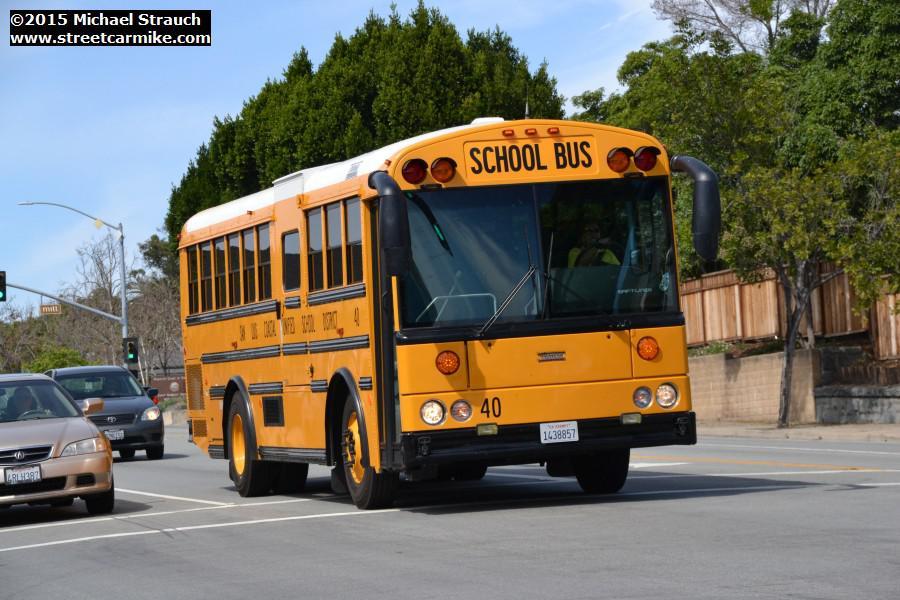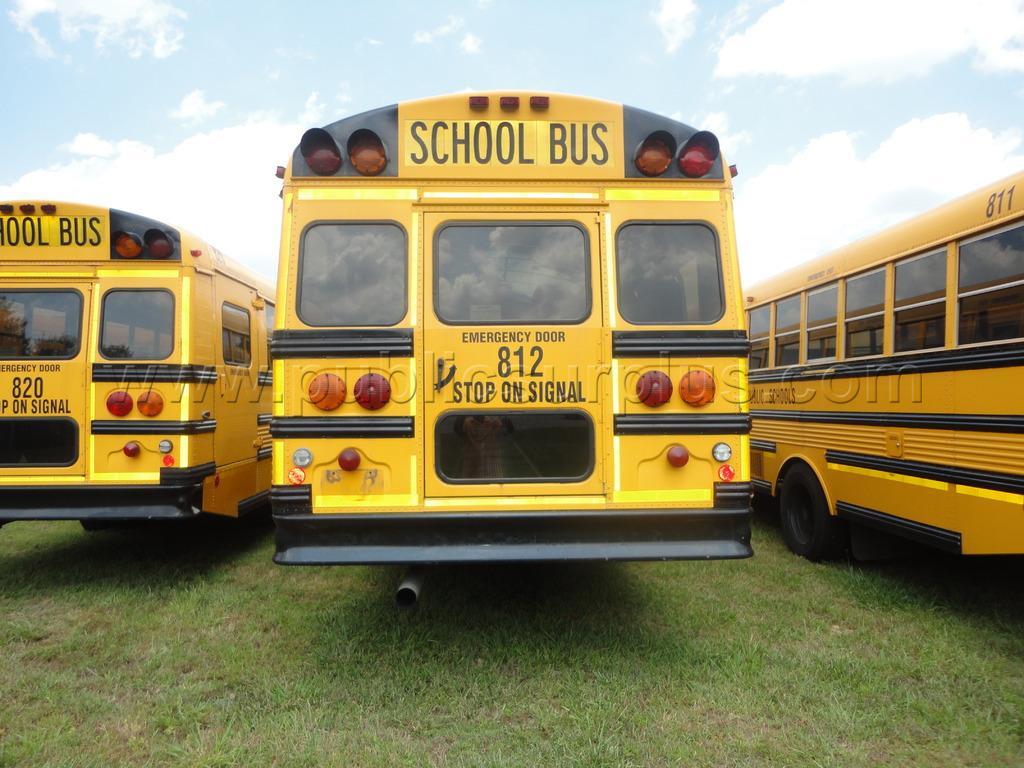The first image is the image on the left, the second image is the image on the right. Given the left and right images, does the statement "There is a school bus on a street with yellow lines and the stopsign on the bus is visible" hold true? Answer yes or no. No. The first image is the image on the left, the second image is the image on the right. Analyze the images presented: Is the assertion "the left and right image contains the same number of buses." valid? Answer yes or no. No. 